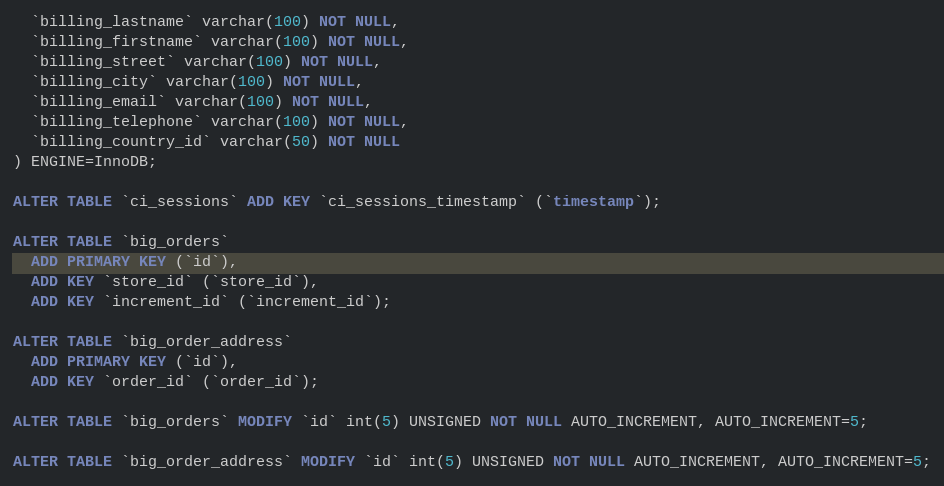Convert code to text. <code><loc_0><loc_0><loc_500><loc_500><_SQL_>  `billing_lastname` varchar(100) NOT NULL,
  `billing_firstname` varchar(100) NOT NULL,
  `billing_street` varchar(100) NOT NULL,
  `billing_city` varchar(100) NOT NULL,
  `billing_email` varchar(100) NOT NULL,
  `billing_telephone` varchar(100) NOT NULL,
  `billing_country_id` varchar(50) NOT NULL
) ENGINE=InnoDB;

ALTER TABLE `ci_sessions` ADD KEY `ci_sessions_timestamp` (`timestamp`);

ALTER TABLE `big_orders`
  ADD PRIMARY KEY (`id`),
  ADD KEY `store_id` (`store_id`),
  ADD KEY `increment_id` (`increment_id`);

ALTER TABLE `big_order_address`
  ADD PRIMARY KEY (`id`),
  ADD KEY `order_id` (`order_id`);

ALTER TABLE `big_orders` MODIFY `id` int(5) UNSIGNED NOT NULL AUTO_INCREMENT, AUTO_INCREMENT=5;

ALTER TABLE `big_order_address` MODIFY `id` int(5) UNSIGNED NOT NULL AUTO_INCREMENT, AUTO_INCREMENT=5;


</code> 